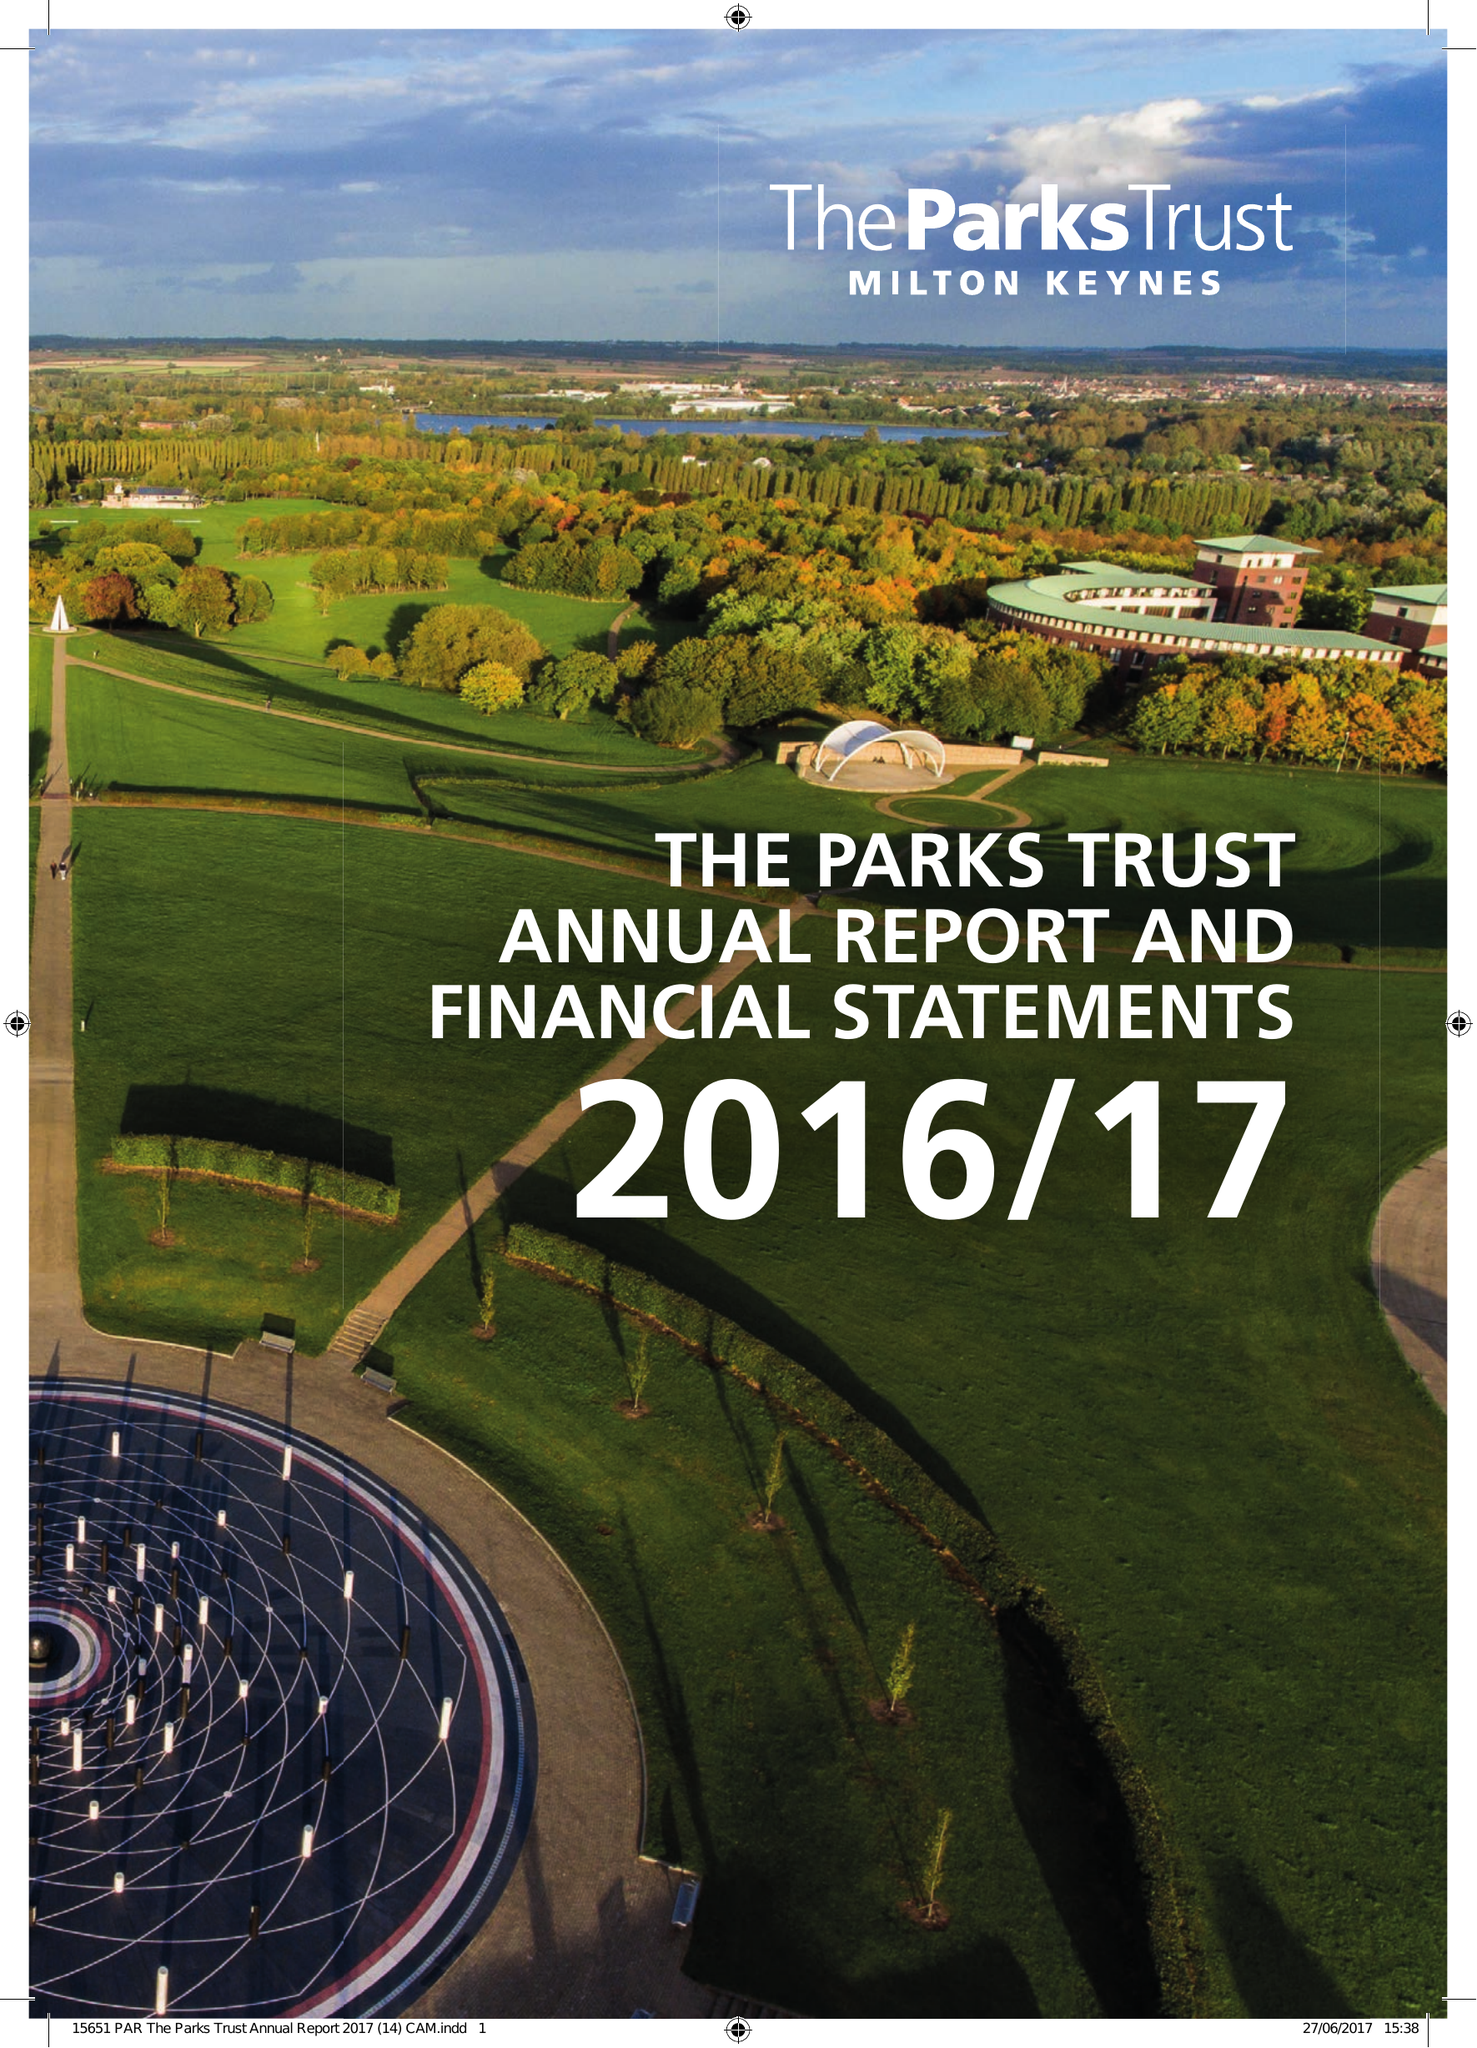What is the value for the address__post_town?
Answer the question using a single word or phrase. MILTON KEYNES 